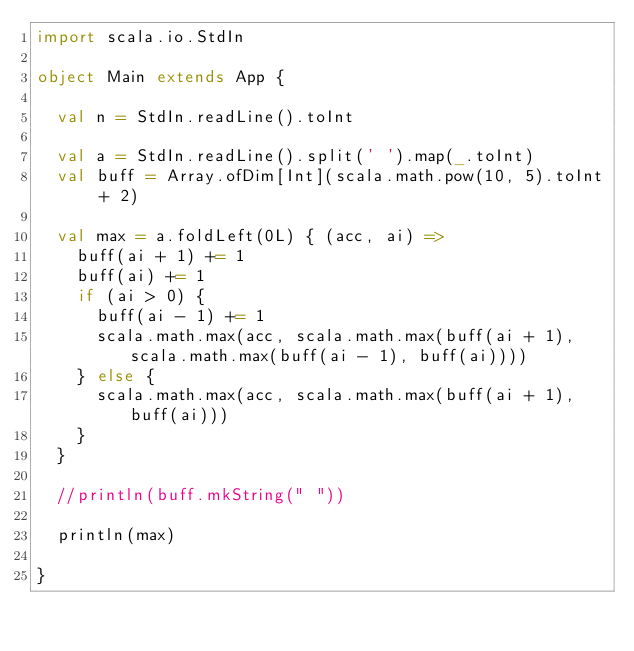Convert code to text. <code><loc_0><loc_0><loc_500><loc_500><_Scala_>import scala.io.StdIn

object Main extends App {

  val n = StdIn.readLine().toInt

  val a = StdIn.readLine().split(' ').map(_.toInt)
  val buff = Array.ofDim[Int](scala.math.pow(10, 5).toInt + 2)

  val max = a.foldLeft(0L) { (acc, ai) =>
    buff(ai + 1) += 1
    buff(ai) += 1
    if (ai > 0) {
      buff(ai - 1) += 1
      scala.math.max(acc, scala.math.max(buff(ai + 1), scala.math.max(buff(ai - 1), buff(ai))))
    } else {
      scala.math.max(acc, scala.math.max(buff(ai + 1), buff(ai)))
    }
  }

  //println(buff.mkString(" "))

  println(max)

}
</code> 